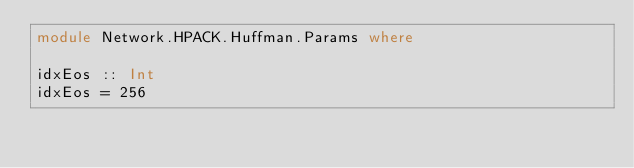<code> <loc_0><loc_0><loc_500><loc_500><_Haskell_>module Network.HPACK.Huffman.Params where

idxEos :: Int
idxEos = 256
</code> 